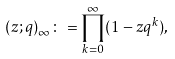Convert formula to latex. <formula><loc_0><loc_0><loc_500><loc_500>( z ; q ) _ { \infty } \colon = \prod _ { k = 0 } ^ { \infty } ( 1 - z q ^ { k } ) ,</formula> 